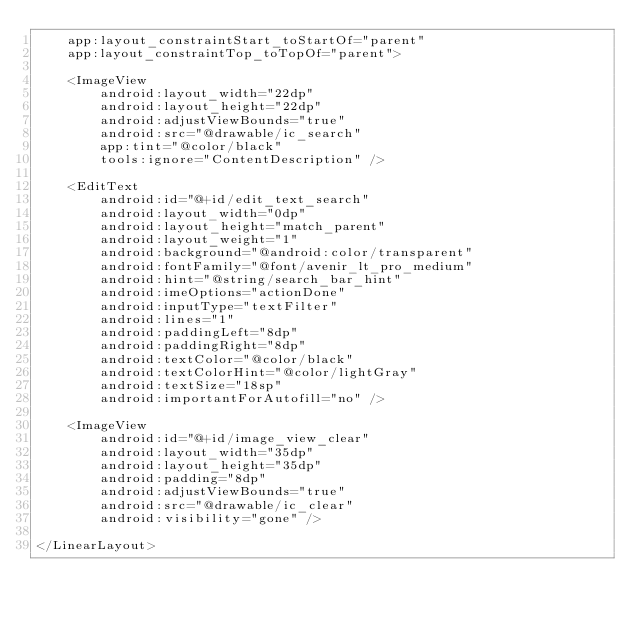Convert code to text. <code><loc_0><loc_0><loc_500><loc_500><_XML_>    app:layout_constraintStart_toStartOf="parent"
    app:layout_constraintTop_toTopOf="parent">

    <ImageView
        android:layout_width="22dp"
        android:layout_height="22dp"
        android:adjustViewBounds="true"
        android:src="@drawable/ic_search"
        app:tint="@color/black"
        tools:ignore="ContentDescription" />

    <EditText
        android:id="@+id/edit_text_search"
        android:layout_width="0dp"
        android:layout_height="match_parent"
        android:layout_weight="1"
        android:background="@android:color/transparent"
        android:fontFamily="@font/avenir_lt_pro_medium"
        android:hint="@string/search_bar_hint"
        android:imeOptions="actionDone"
        android:inputType="textFilter"
        android:lines="1"
        android:paddingLeft="8dp"
        android:paddingRight="8dp"
        android:textColor="@color/black"
        android:textColorHint="@color/lightGray"
        android:textSize="18sp"
        android:importantForAutofill="no" />

    <ImageView
        android:id="@+id/image_view_clear"
        android:layout_width="35dp"
        android:layout_height="35dp"
        android:padding="8dp"
        android:adjustViewBounds="true"
        android:src="@drawable/ic_clear"
        android:visibility="gone" />

</LinearLayout></code> 